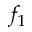Convert formula to latex. <formula><loc_0><loc_0><loc_500><loc_500>f _ { 1 }</formula> 